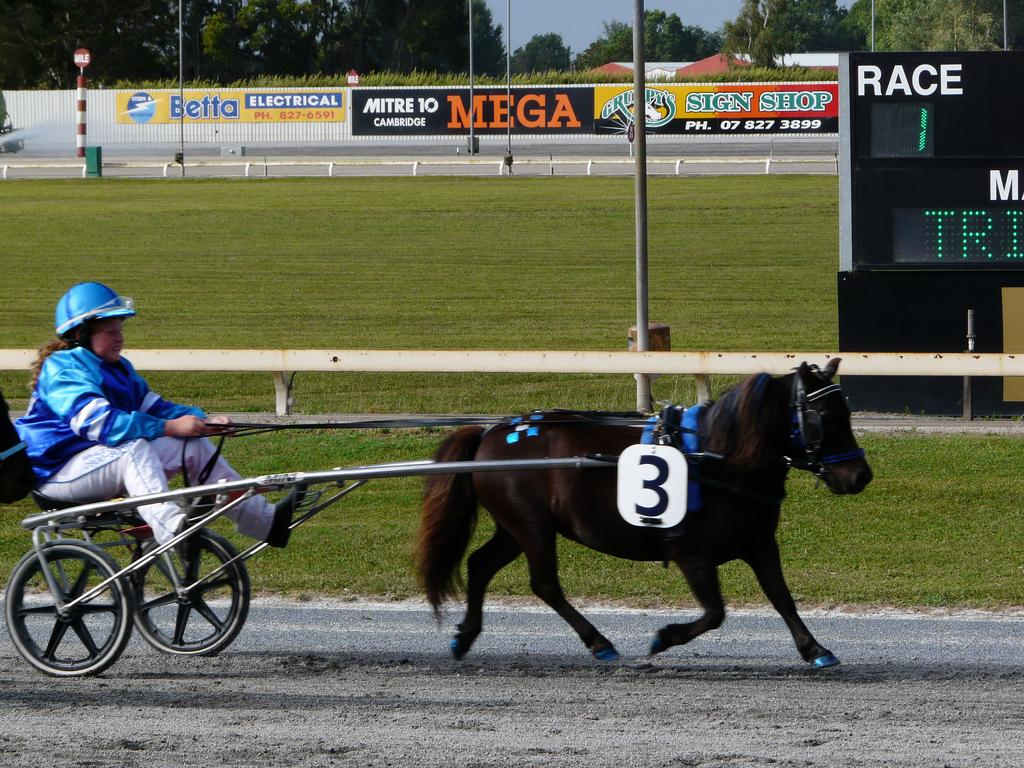Discuss any notable accessories or equipment present in the image. The horse is wearing a black and blue halter with blinders, a long set of reins, and the rider sports a blue helmet and jacket. They travel along a silver racetrack encompassing a green lawn. Using descriptive language, mention the setting of the image. Surrounded by a green grassy area and a silver racetrack, the image captures the essence of an exciting equestrian event replete with vibrant colors and dynamic action. Provide a brief description of the most prominent elements in the image. A dark brown horse is running, pulling a cart with a woman in a blue hat and jacket. The horse has a number 3 on it, and the scene is set on a green grassy field and grey racetrack. Describe the image focusing on the details of the horse. The horse is a dark brown color with a brown tail and a mane with blue highlights. It has a blue number 3 on its body and is wearing black and blue halter with blinders.  Describe the color theme present in the image. The image has a mix of blue in the rider's attire, green in the grass and background, and grey for the racetrack. The horse is dark brown with a blue-tinged mane, and the cart has black wheels. In a single sentence, sum up the main focus of the image. The image showcases a dark brown horse adorned with the number 3, racing along a track while pulling a cart driven by a young girl in blue attire. Use poetic language to describe the scene in the image. In the vast expanse of verdant pastures, a gallant steed fiercely races, its mane adorned with blue, effortlessly guiding its rider through the silver road. Explain what the rider is wearing and doing in the image. The rider, a young girl, is wearing a blue hat, blue jacket, and grey and blue pants. She seems to be driving the horse as it pulls a cart along the racetrack. Mention the primary action taking place in the image. A dark brown running horse is pulling a cart with a young girl wearing a bright blue riding helmet and jacket at what appears to be a racetrack. Describe the attire of the young girl in the image. The young girl is wearing a bright blue riding helmet, a blue jacket with a stripe on the sleeve, and grey and blue pants as she guides the horse and drives the cart. Find the pink balloon in the top-left corner of the image. There is no mention of a pink balloon in any of the captions, so this element doesn't exist in the image. Does the man have a beard? There is no mention of a man with or without a beard in any of the captions, so this attribute doesn't exist in the image. Identify the type of fruit growing on the tree. There is no mention of a tree with fruits on it in any of the captions, so this object doesn't exist in the image. Describe the pattern on the yellow umbrella. There is no mention of a yellow umbrella in any of the captions, so this object doesn't exist in the image. Identify the attribute that differentiates the blue car from the red car. There are no cars mentioned in the captions, so this element doesn't exist in the image. Which of the dogs is wearing a red collar? There is no mention of dogs or red collars in any of the captions, so this element doesn't exist in the image. Which child is playing with a toy airplane? There is no mention of children or a toy airplane in any of the captions, so this activity doesn't exist in the image. What color is the kite in the sky? There is no mention of a kite or the sky in any of the captions, so this object doesn't exist in the image. Point out the interaction between the cat and the bird. There is no mention of a cat or a bird in any of the captions, so this interaction doesn't exist in the image. How many people are riding bicycles in the image? There is no mention of people riding bicycles in any of the captions, so this activity doesn't exist in the image. 